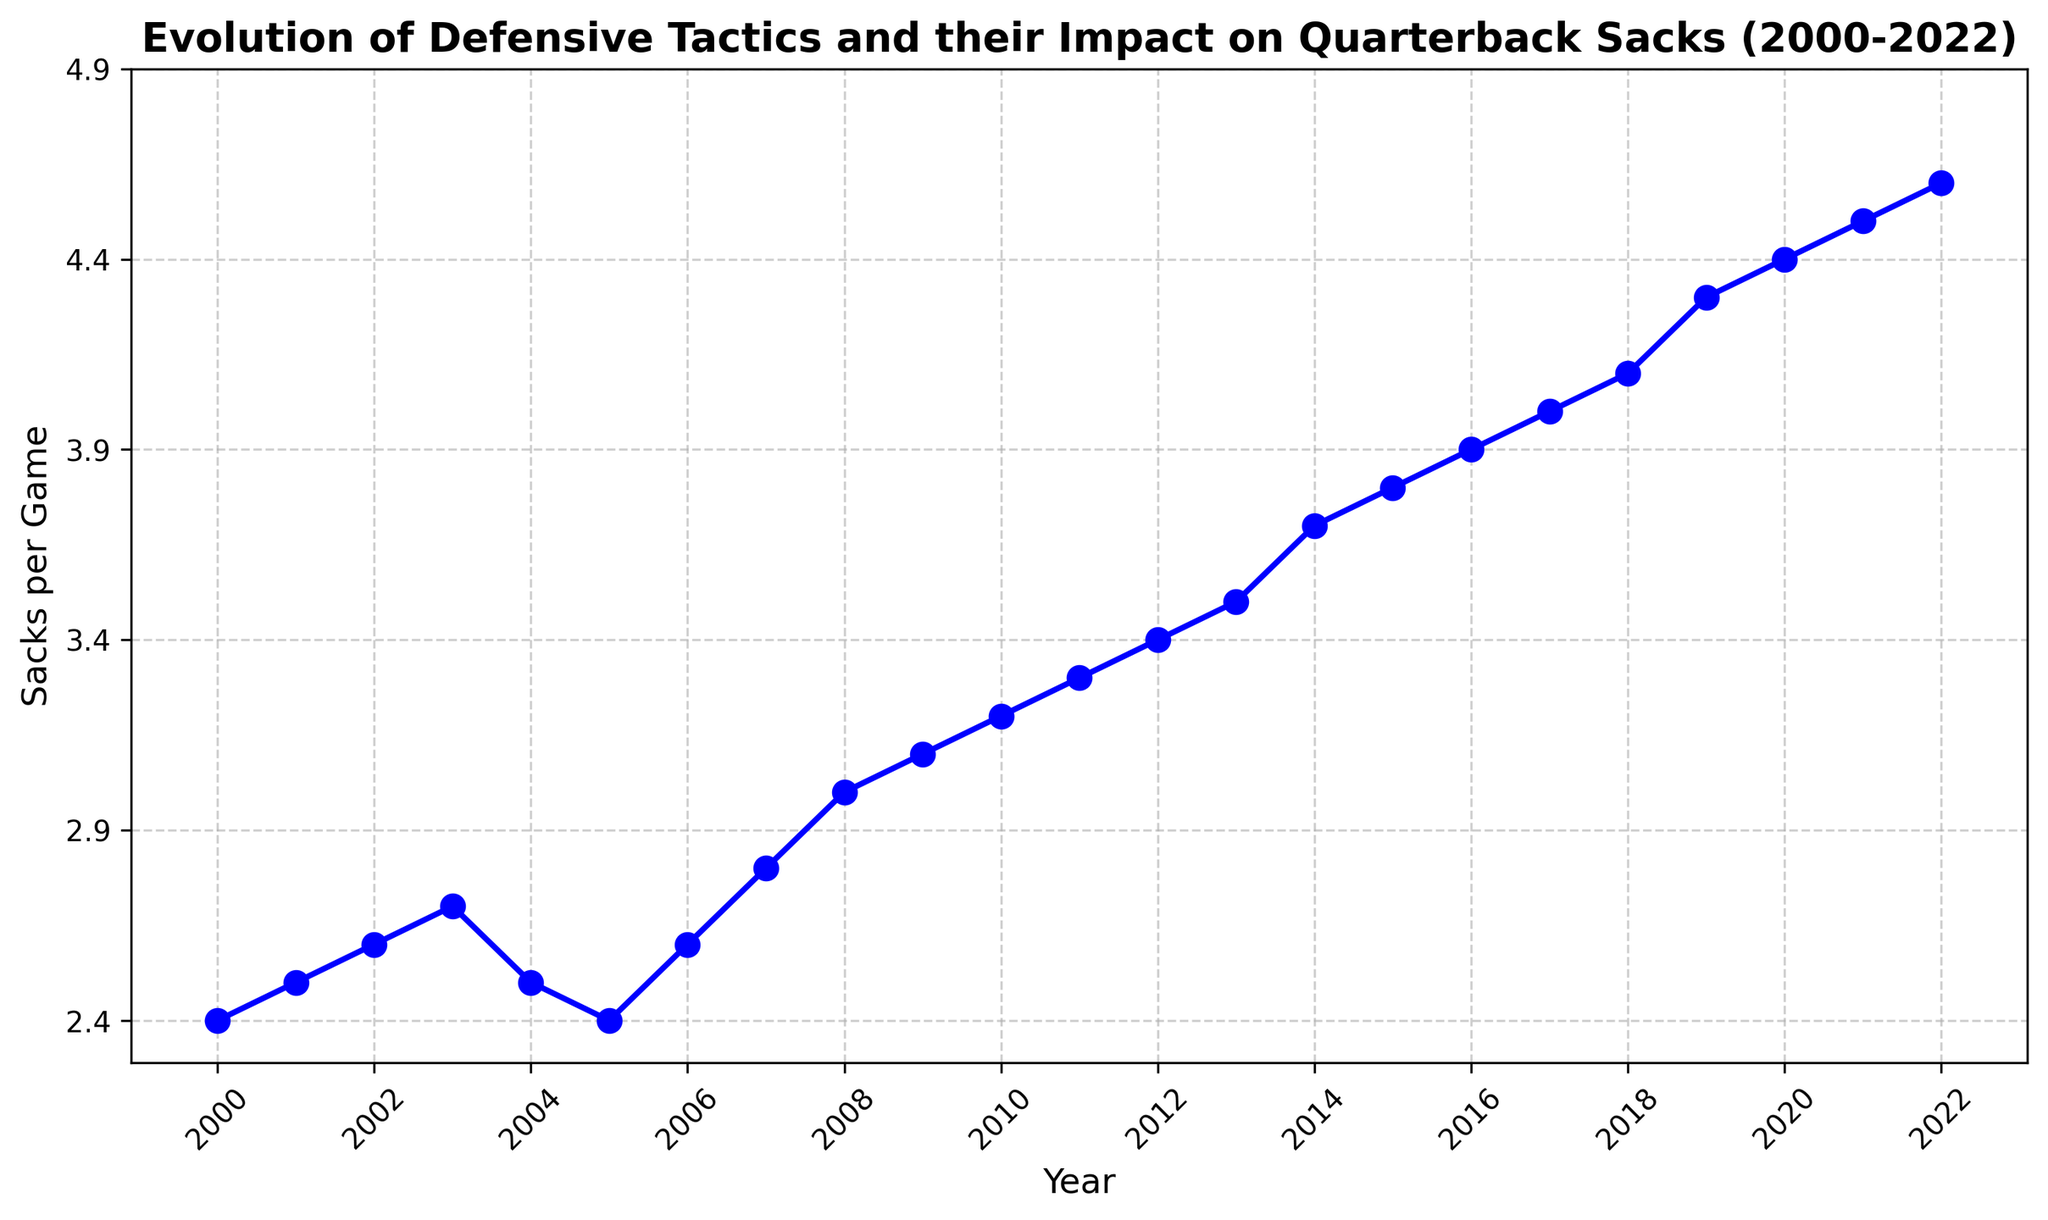How has the number of sacks per game changed from 2000 to 2022? By looking at the line chart from the year 2000 to 2022, I can see a general increasing trend in the sacks per game. The value starts at 2.4 sacks per game in 2000 and rises to 4.6 sacks per game in 2022.
Answer: It has increased In which year did the sacks per game see the steepest increase? From the chart, the slope between consecutive points represents the rate of increase. The steepest increase can be identified between the years where the line ascends the most sharply. From 2007 to 2009 (i.e., from 2.8 to 3.1) and from 2018 to 2019 (i.e., from 4.1 to 4.3) have the steepest visible increase.
Answer: 2008–2009 What is the overall trend in sacks per game over the years? Observing the line from 2000 to 2022, the general trend is upward, indicating an increase in the average number of sacks per game over the years. The line shows a consistent rise with minor fluctuations around 2004–2006.
Answer: Upward trend Compare the sacks per game in 2001 and 2012. Which year had more sacks per game? From the chart, the value for 2001 is 2.5 sacks per game, and the value for 2012 is 3.4 sacks per game. Thus, 2012 had more sacks per game.
Answer: 2012 What is the average number of sacks per game from 2010 to 2020? To find the average number of sacks per game from 2010 to 2020, sum up the number of sacks per game for each year from 2010 to 2020 and then divide by the number of years. (3.2 + 3.3 + 3.4 + 3.5 + 3.7 + 3.8 + 3.9 + 4.0 + 4.1 + 4.3 + 4.4) = 41.6, dividing by 11 gives the average: 41.6 / 11 = ~3.78
Answer: ~3.78 Identify any years with a decrease in sacks per game compared to the previous year. By viewing the year-to-year changes in the plot, we can identify years where the line descends (indicating a decrease). There is a decrease from 2003 to 2004 (from 2.7 to 2.5) and from 2005 to 2006 (from 2.4 to 2.6).
Answer: 2004, 2006 What was the number of sacks per game in 2015 and how did it compare to 2014? According to the chart, the number of sacks per game in 2015 was 3.8, compared to 3.7 in 2014. Therefore, the number of sacks per game increased from 2014 to 2015.
Answer: 3.8; increased Which year had the highest number of sacks per game? Observing the chart, the highest point on the line represents the highest number of sacks per game. This highest point can be seen in 2022 with 4.6 sacks per game.
Answer: 2022 Based on the visual attributes, how does the average number of sacks per game in the 2000s (2000-2009) compare to that in the 2010s (2010-2019)? To compare these periods visually, the line in the 2010s appears higher than in the 2000s. Checked by averaging the data points: the average in 2000s is (2.4+2.5+2.6+2.7+2.5+2.4+2.6+2.8+3.0+3.1)/10 = 2.66, and in 2010s it is (3.2+3.3+3.4+3.5+3.7+3.8+3.9+4.0+4.1+4.3)/10 = ~3.72. Thus, the 2010s had a higher average.
Answer: The 2010s had a higher average 